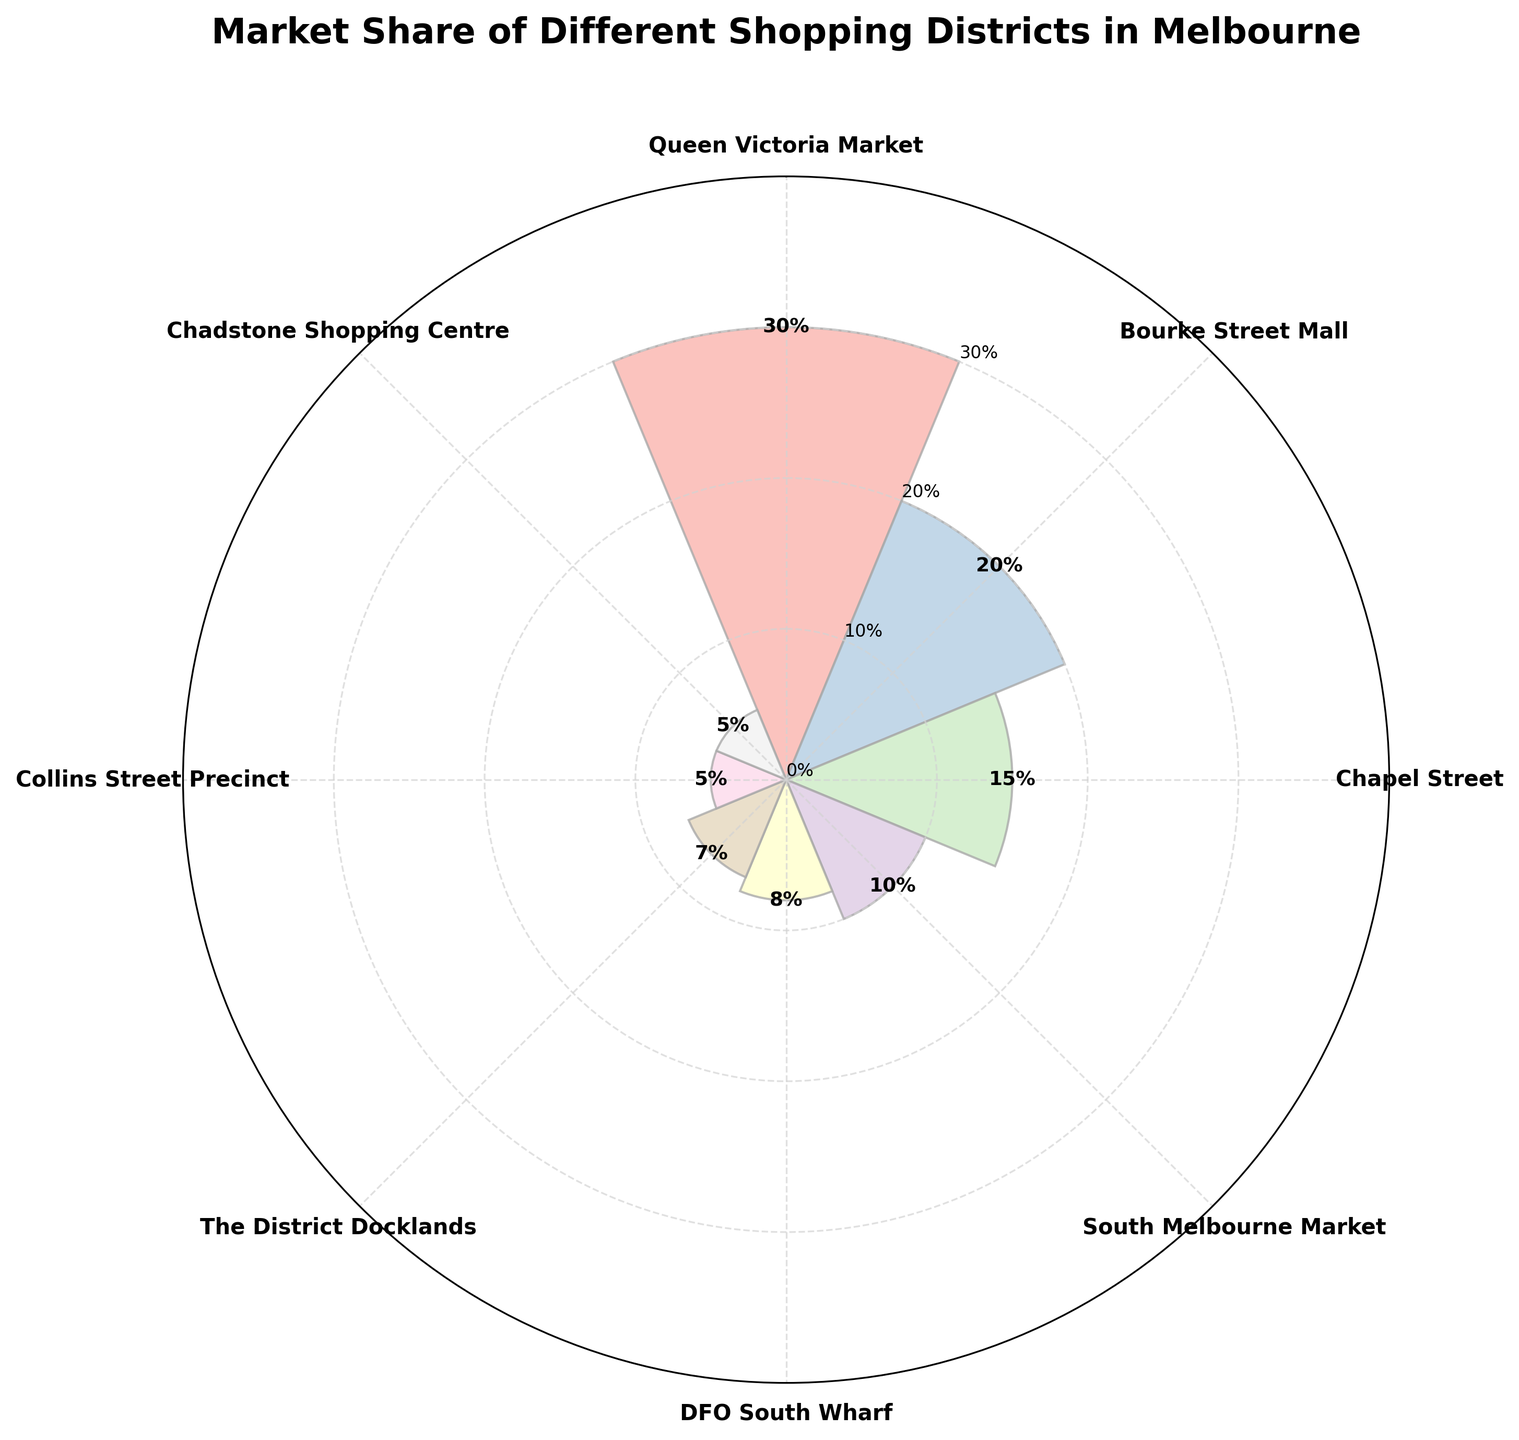What's the title of the chart? The title is situated at the top of the chart. It is designed to succinctly summarize what the chart represents.
Answer: Market Share of Different Shopping Districts in Melbourne How many shopping districts are displayed in the chart? By counting the distinct market district names labeled around the circular axis, we can determine the number of districts shown.
Answer: 8 Which shopping district has the largest market share and what is the percentage? Look for the bar that extends the furthest from the center and check its associated label and percentage value.
Answer: Queen Victoria Market with 30% What is the combined market share of Chapel Street and South Melbourne Market? Find and sum the market share percentages for Chapel Street and South Melbourne Market.
Answer: 15% + 10% = 25% Which district has a larger market share: DFO South Wharf or The District Docklands? Compare the bar lengths and the associated percentages for both districts to determine which one is larger.
Answer: DFO South Wharf with 8% What's the market share difference between Queen Victoria Market and Bourke Street Mall? Subtract the market share percentage of Bourke Street Mall from Queen Victoria Market to find the difference.
Answer: 30% - 20% = 10% How many districts have a market share below 10%? Identify and count the bars (and their respective labels and percentages) that have a value less than 10%.
Answer: 3 Are there any districts with equal market shares? If so, which ones? Examine the labeled percentages around the chart and check if any two districts have the same value.
Answer: Collins Street Precinct and Chadstone Shopping Centre, both with 5% What is the average market share of all the districts combined? Sum all the market share percentages and divide by the number of districts to find the average. (30 + 20 + 15 + 10 + 8 + 7 + 5 + 5) / 8 = 12.5%
Answer: 12.5% Which district appears immediately counter-clockwise from The District Docklands on the chart? Locate The District Docklands on the circular axis and identify the district positioned just counter-clockwise from it.
Answer: Collins Street Precinct 